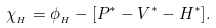<formula> <loc_0><loc_0><loc_500><loc_500>\chi _ { _ { H } } = \phi _ { _ { H } } - [ P ^ { * } - V ^ { * } - H ^ { * } ] .</formula> 